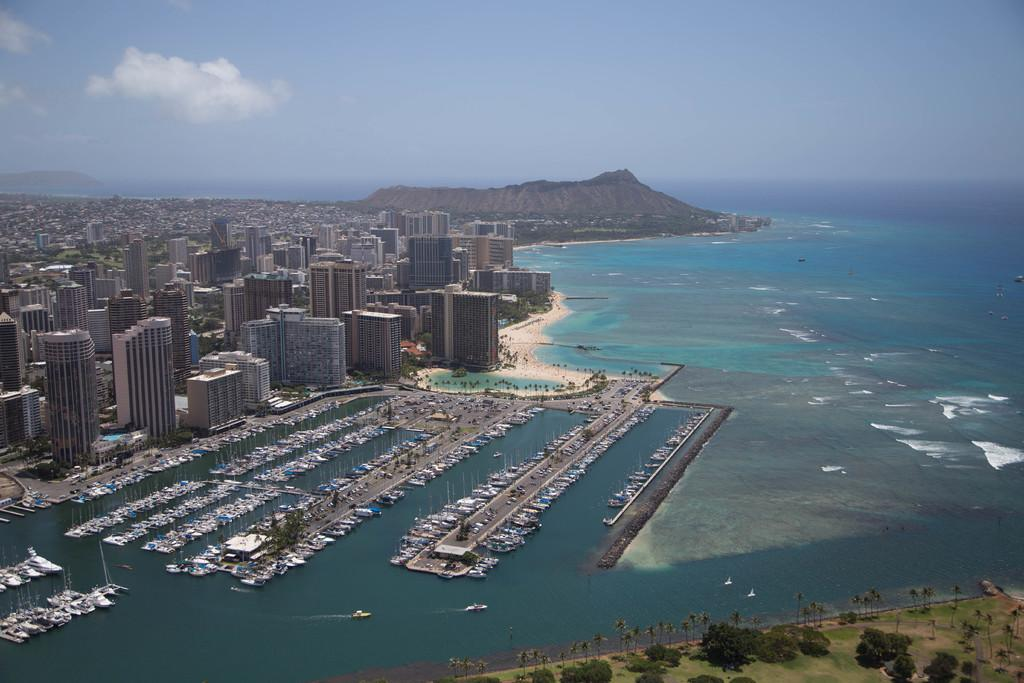What type of structures can be seen in the image? There are buildings in the image. What natural feature is visible in the image? There is a mountain in the image. What is the water in the image used for? Boats are on the water in the image, suggesting it is a body of water for transportation or recreation. What can be seen in the background of the image? The sky is visible in the background of the image. What type of vegetation is present in the image? Trees are present in the image. Where is the mine located in the image? There is no mine present in the image. What type of club can be seen in the image? There is no club present in the image. 